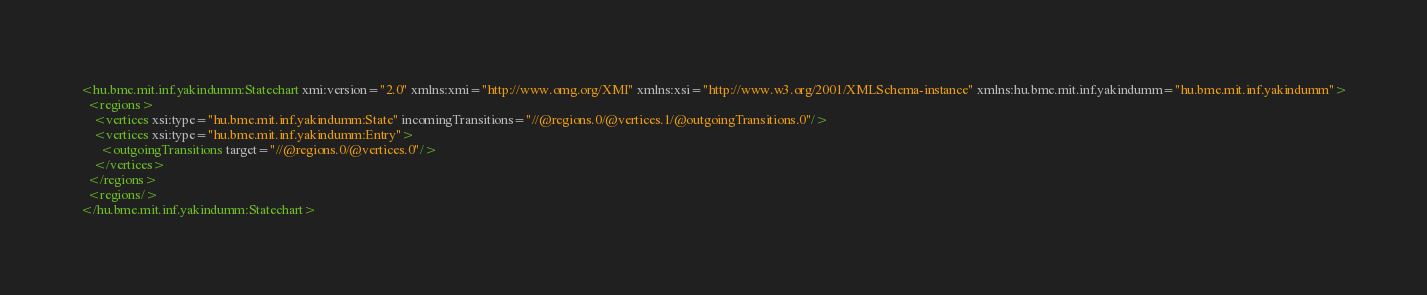Convert code to text. <code><loc_0><loc_0><loc_500><loc_500><_XML_><hu.bme.mit.inf.yakindumm:Statechart xmi:version="2.0" xmlns:xmi="http://www.omg.org/XMI" xmlns:xsi="http://www.w3.org/2001/XMLSchema-instance" xmlns:hu.bme.mit.inf.yakindumm="hu.bme.mit.inf.yakindumm">
  <regions>
    <vertices xsi:type="hu.bme.mit.inf.yakindumm:State" incomingTransitions="//@regions.0/@vertices.1/@outgoingTransitions.0"/>
    <vertices xsi:type="hu.bme.mit.inf.yakindumm:Entry">
      <outgoingTransitions target="//@regions.0/@vertices.0"/>
    </vertices>
  </regions>
  <regions/>
</hu.bme.mit.inf.yakindumm:Statechart>
</code> 